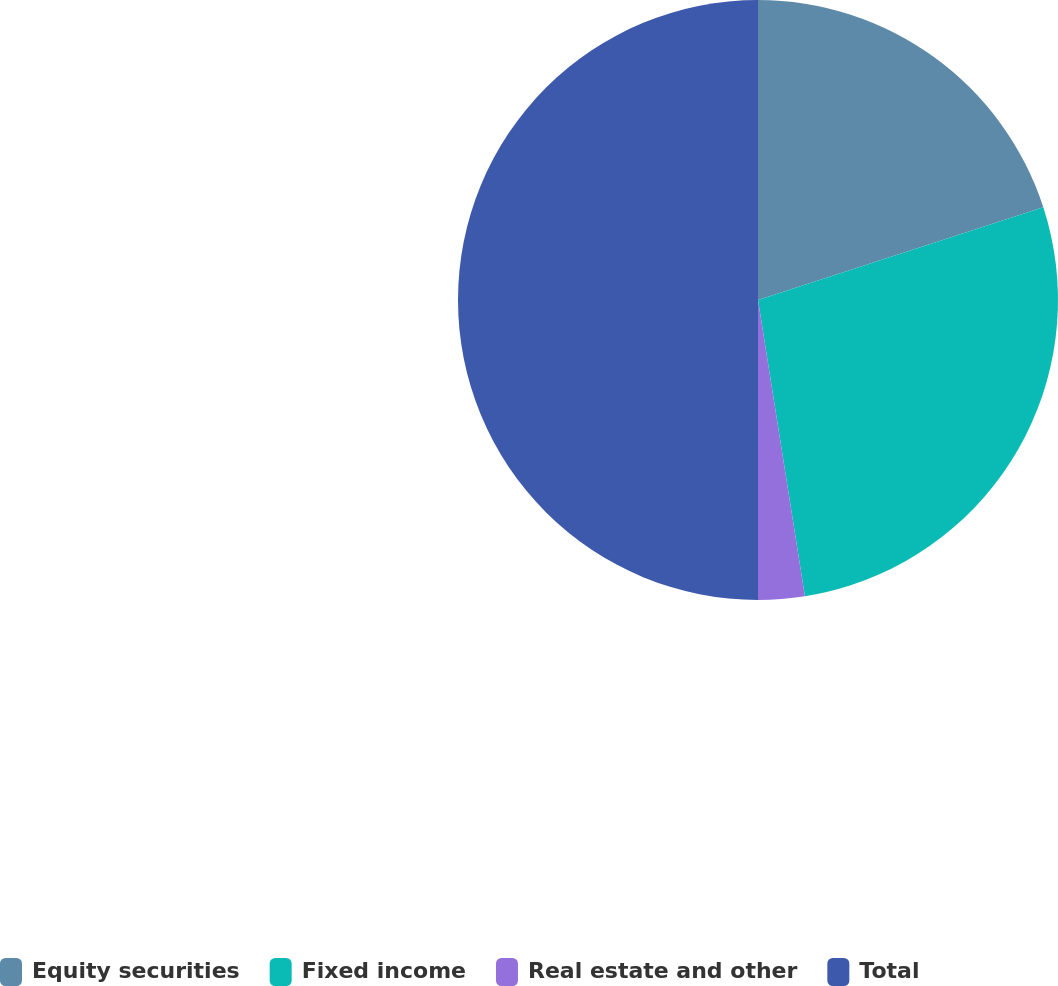Convert chart. <chart><loc_0><loc_0><loc_500><loc_500><pie_chart><fcel>Equity securities<fcel>Fixed income<fcel>Real estate and other<fcel>Total<nl><fcel>20.0%<fcel>27.5%<fcel>2.5%<fcel>50.0%<nl></chart> 